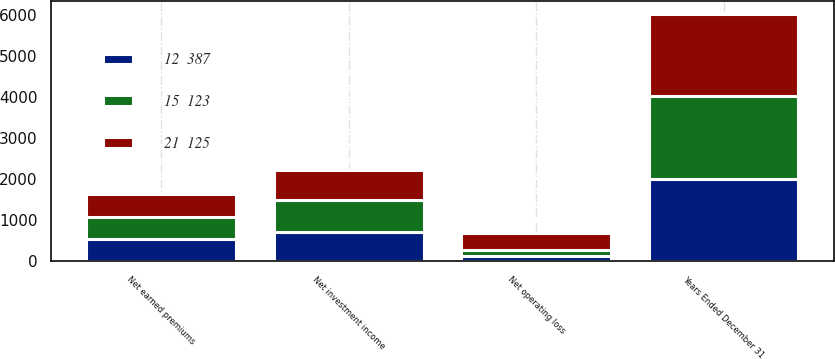<chart> <loc_0><loc_0><loc_500><loc_500><stacked_bar_chart><ecel><fcel>Years Ended December 31<fcel>Net earned premiums<fcel>Net investment income<fcel>Net operating loss<nl><fcel>15  123<fcel>2016<fcel>536<fcel>783<fcel>146<nl><fcel>21  125<fcel>2015<fcel>548<fcel>721<fcel>399<nl><fcel>12  387<fcel>2014<fcel>556<fcel>723<fcel>138<nl></chart> 